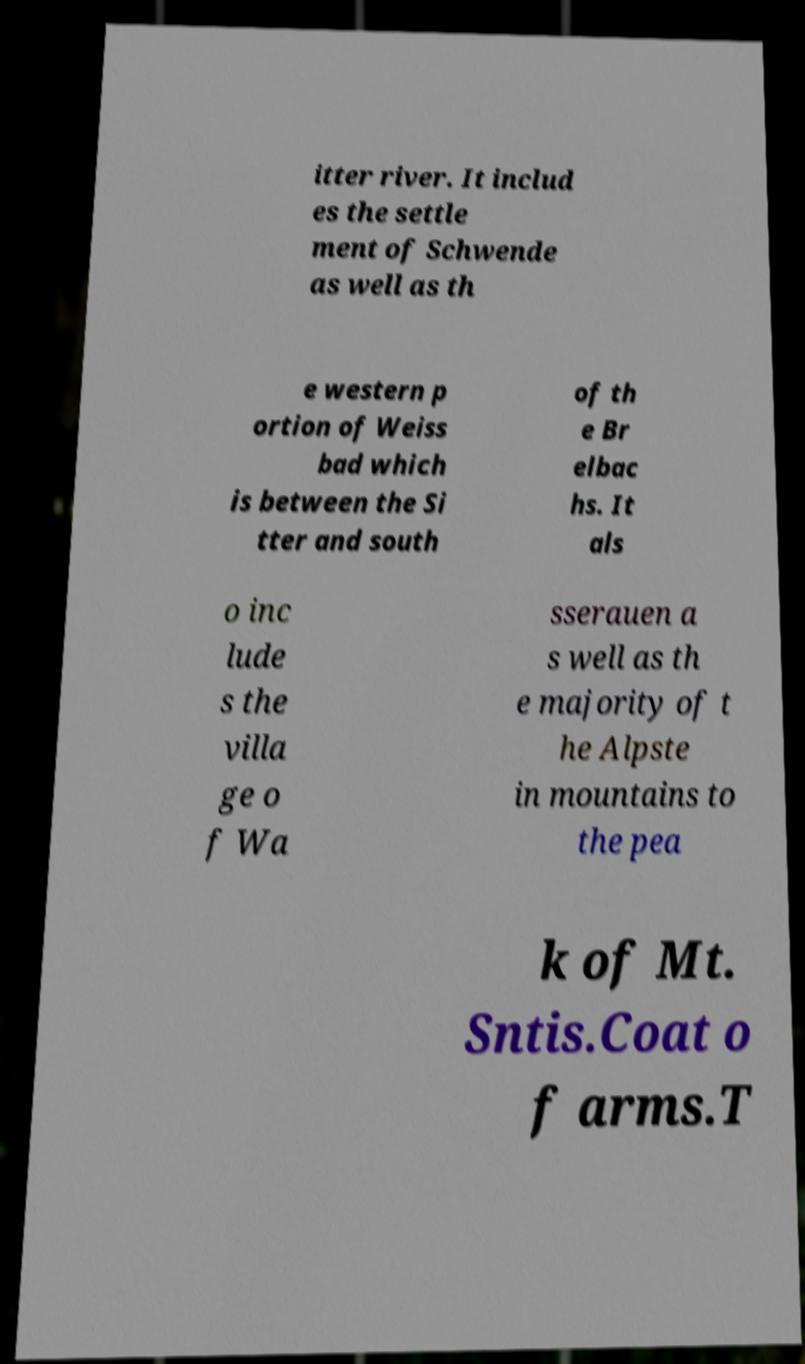Please identify and transcribe the text found in this image. itter river. It includ es the settle ment of Schwende as well as th e western p ortion of Weiss bad which is between the Si tter and south of th e Br elbac hs. It als o inc lude s the villa ge o f Wa sserauen a s well as th e majority of t he Alpste in mountains to the pea k of Mt. Sntis.Coat o f arms.T 